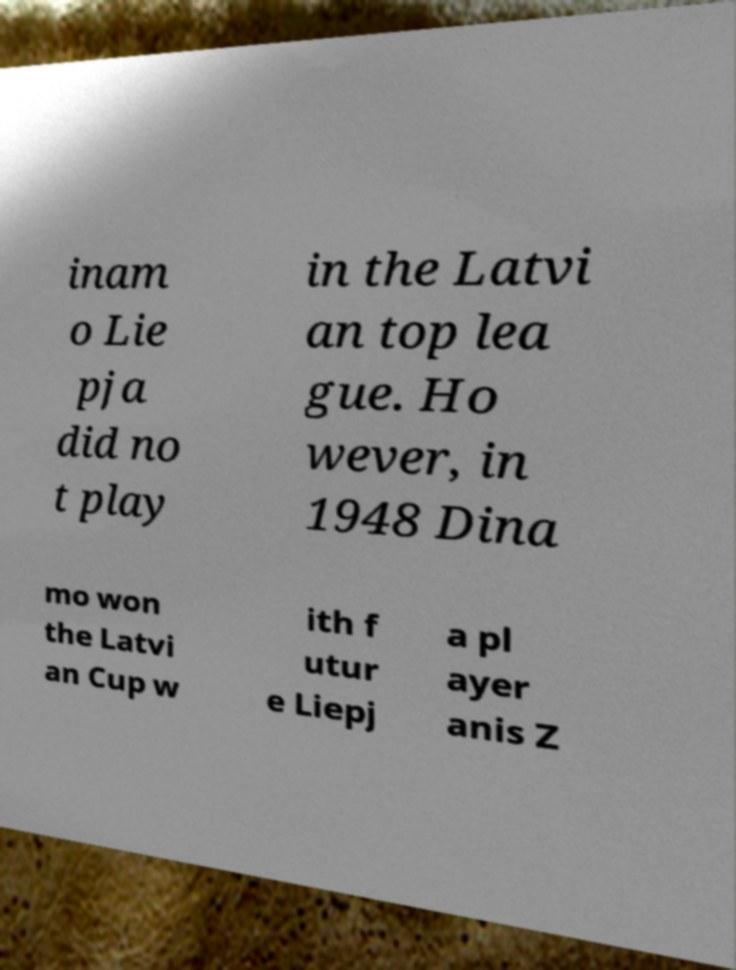Could you assist in decoding the text presented in this image and type it out clearly? inam o Lie pja did no t play in the Latvi an top lea gue. Ho wever, in 1948 Dina mo won the Latvi an Cup w ith f utur e Liepj a pl ayer anis Z 